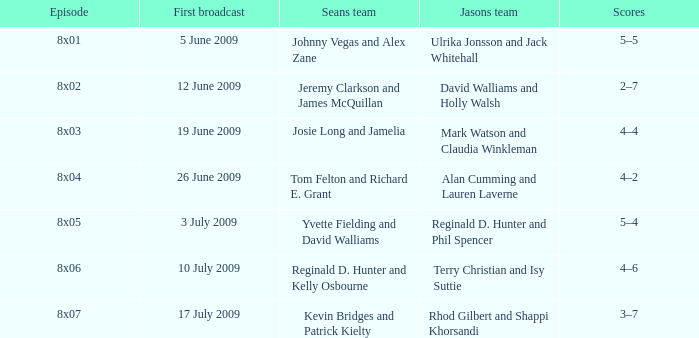Which individuals made up jason's team during the episode aired on june 12, 2009? David Walliams and Holly Walsh. 